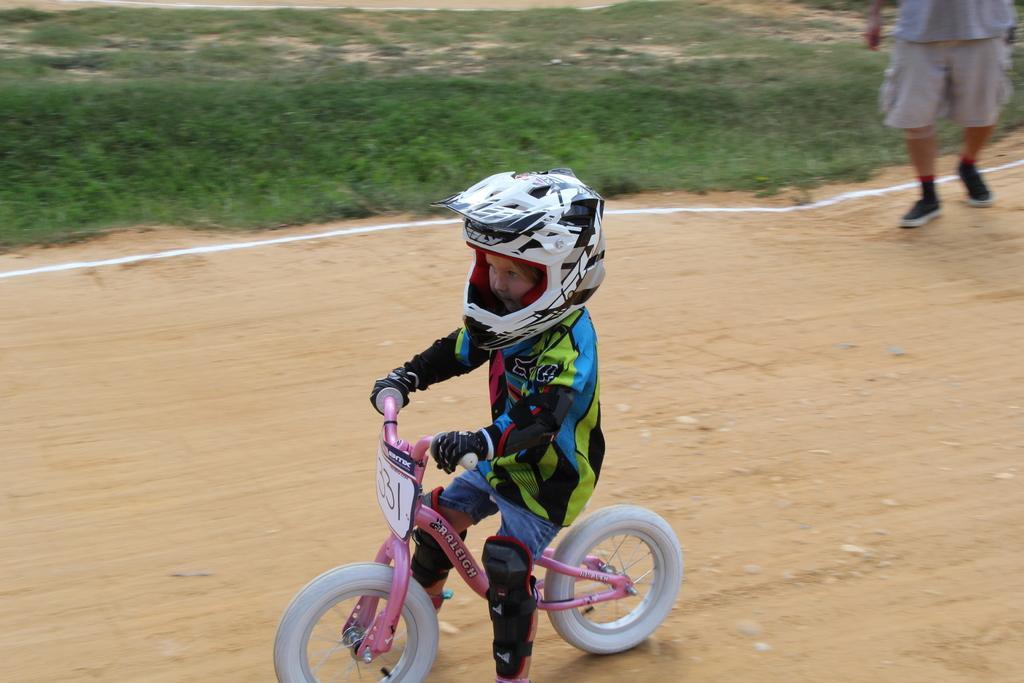Could you give a brief overview of what you see in this image? In this image I can see a child is sitting on a bicycle and wearing helmet on the road. I can also see there is a person on the ground. 